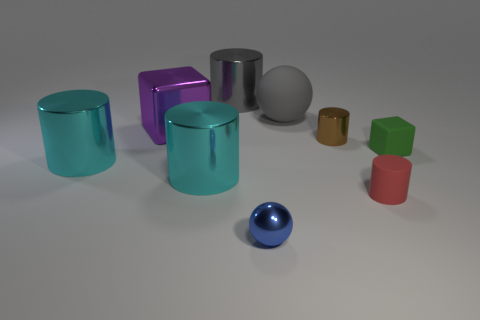Subtract all cyan cylinders. How many cylinders are left? 3 Subtract all large gray metallic cylinders. How many cylinders are left? 4 Subtract all blue cylinders. Subtract all yellow cubes. How many cylinders are left? 5 Subtract all blocks. How many objects are left? 7 Add 7 blue metal objects. How many blue metal objects exist? 8 Subtract 1 green cubes. How many objects are left? 8 Subtract all big gray cylinders. Subtract all big gray spheres. How many objects are left? 7 Add 9 tiny balls. How many tiny balls are left? 10 